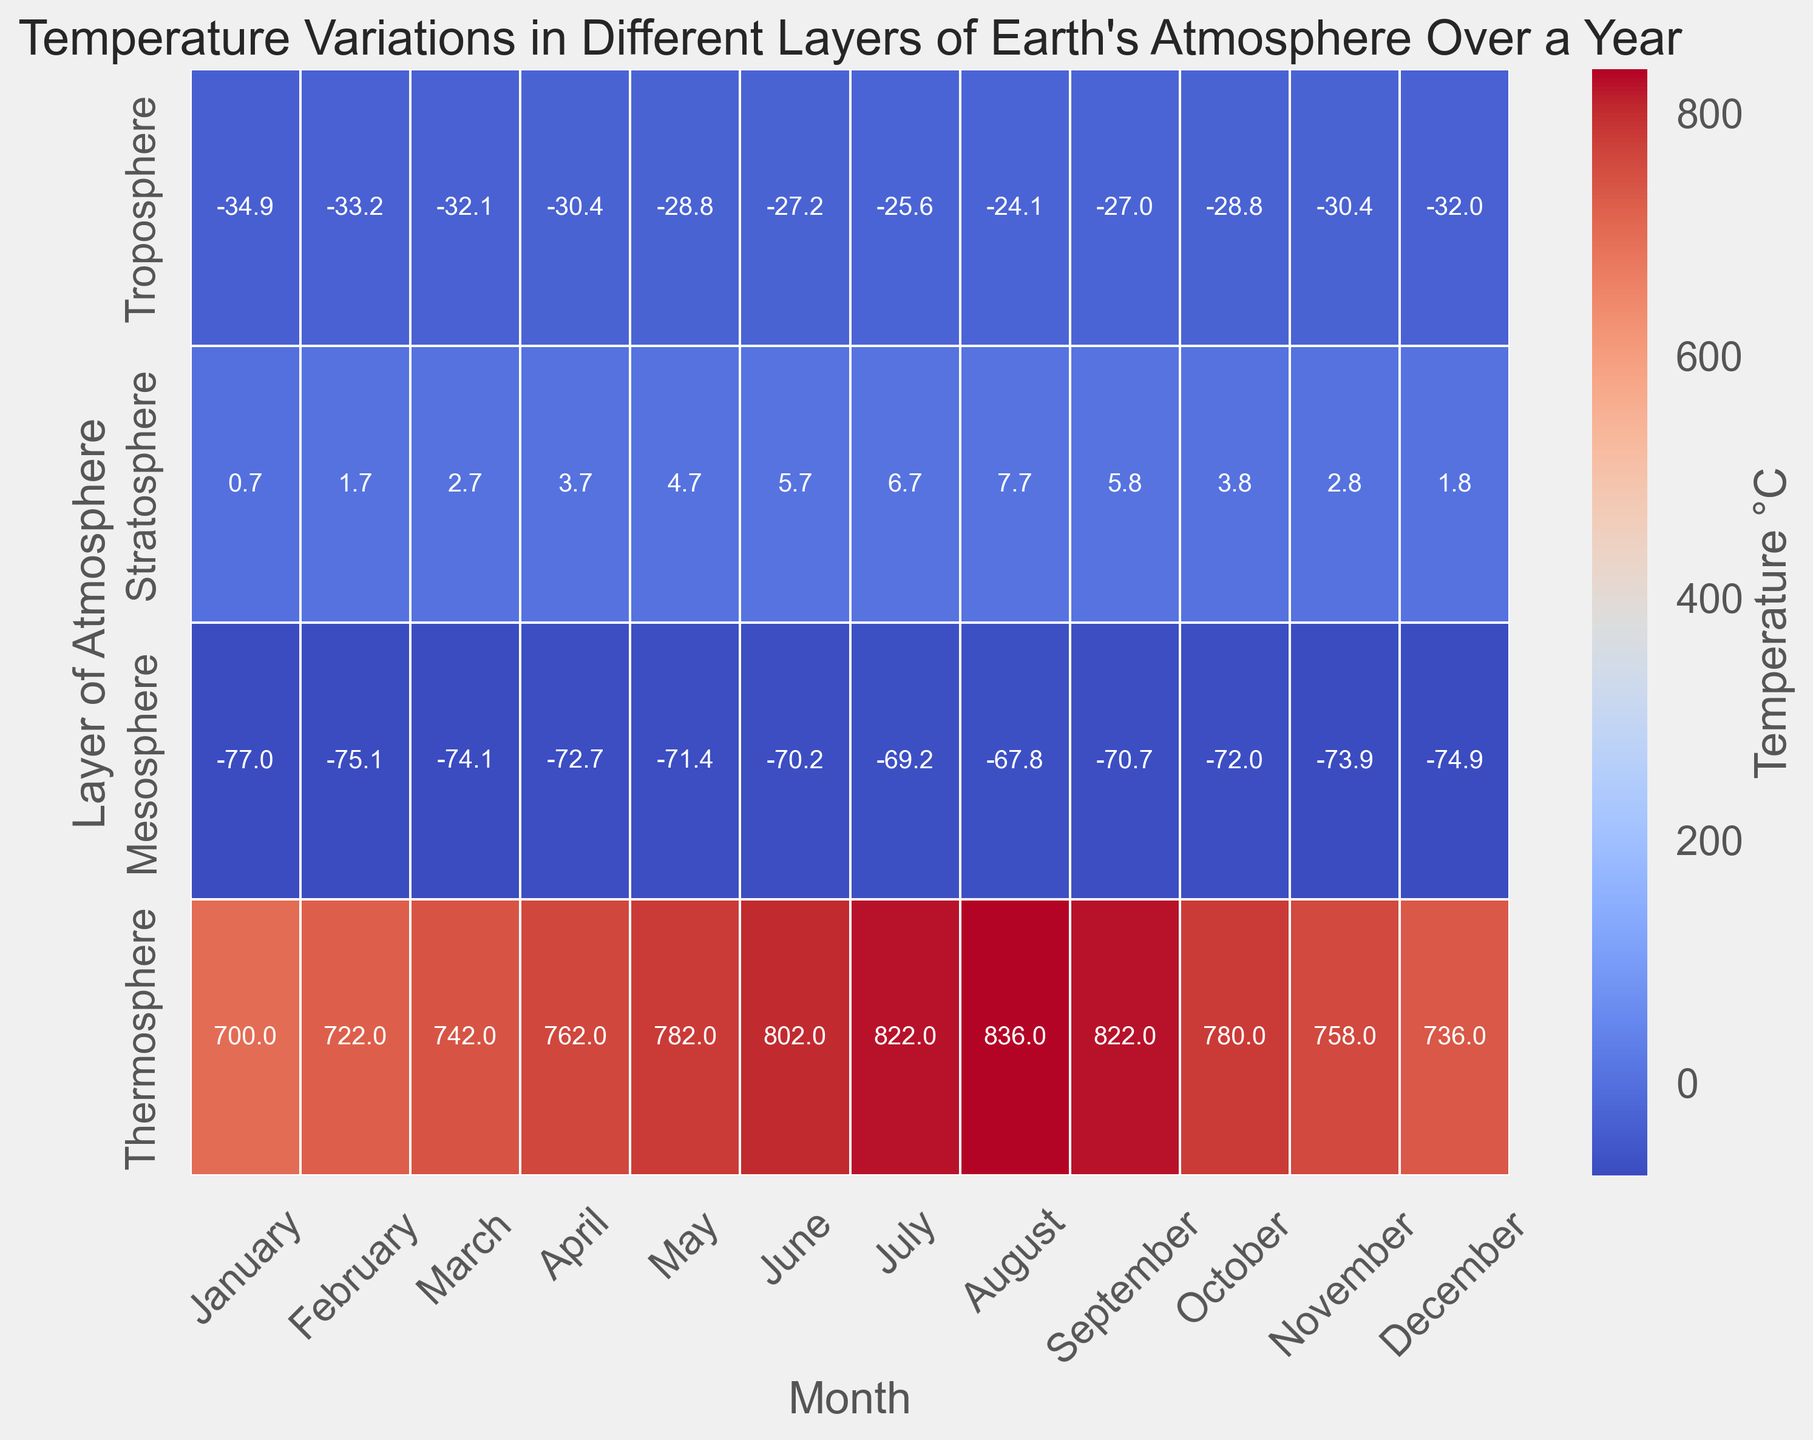What layer has the highest temperature in January? By examining the heatmap for the month of January, we identify the thermosphere as the layer with the highest temperature.
Answer: Thermosphere Which month has the lowest average temperature in the mesosphere layer? To determine this, look across the heatmap for the mesosphere layer and identify the month with the lowest average temperature value.
Answer: January How do the temperature variations between the troposphere and thermosphere differ in July? In July, the troposphere has its temperatures around -50.0 to 0.0°C, while the thermosphere experiences a gradient from 560.0 to 1030.0°C, showing a sharp increase in temperature contrast.
Answer: Troposphere: -50.0 to 0.0°C and Thermosphere: 560.0 to 1030.0°C Which month shows the largest temperature increase when moving from the troposphere to the thermosphere? Calculate the temperature difference from the troposphere to the thermosphere for each month and identify the largest increase.
Answer: August Is there any month where the temperature in the mesosphere is higher than the troposphere? By checking the heatmap, examine all months to see if any case exists where the mesosphere's value surpasses the troposphere's value.
Answer: No Which layer has the least variation in temperature over the year? Observe each layer's color gradient over the months. The least variation indicates more consistent temperatures throughout.
Answer: Stratosphere What is the temperature difference between the stratosphere and mesosphere in December? Check December's temperatures in both the stratosphere (6.0°C) and mesosphere (-56.0°C), then calculate the difference.
Answer: 62.0°C Compare the temperature differences between the troposphere and stratosphere in April and November. Which month has a greater difference? Find the differences for April (-53.0 - 0.5 = -53.5°C) and November (-53.0 - 0.0 = -53.0°C) and compare them.
Answer: April What is the average temperature of the thermosphere in the first half of the year? Sum the thermosphere's temperatures from January to June (500.0 + 510.0 + 520.0 + 530.0 + 540.0 + 550.0 = 3150.0) and divide by 6 months.
Answer: 525.0°C 